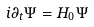<formula> <loc_0><loc_0><loc_500><loc_500>i \partial _ { t } \Psi = H _ { 0 } \Psi</formula> 